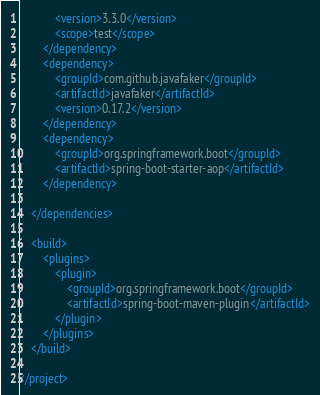<code> <loc_0><loc_0><loc_500><loc_500><_XML_>			<version>3.3.0</version>
			<scope>test</scope>
		</dependency>
		<dependency>
			<groupId>com.github.javafaker</groupId>
			<artifactId>javafaker</artifactId>
			<version>0.17.2</version>
		</dependency>
		<dependency>
			<groupId>org.springframework.boot</groupId>
			<artifactId>spring-boot-starter-aop</artifactId>
		</dependency>

	</dependencies>

	<build>
		<plugins>
			<plugin>
				<groupId>org.springframework.boot</groupId>
				<artifactId>spring-boot-maven-plugin</artifactId>
			</plugin>
		</plugins>
	</build>

</project>
</code> 